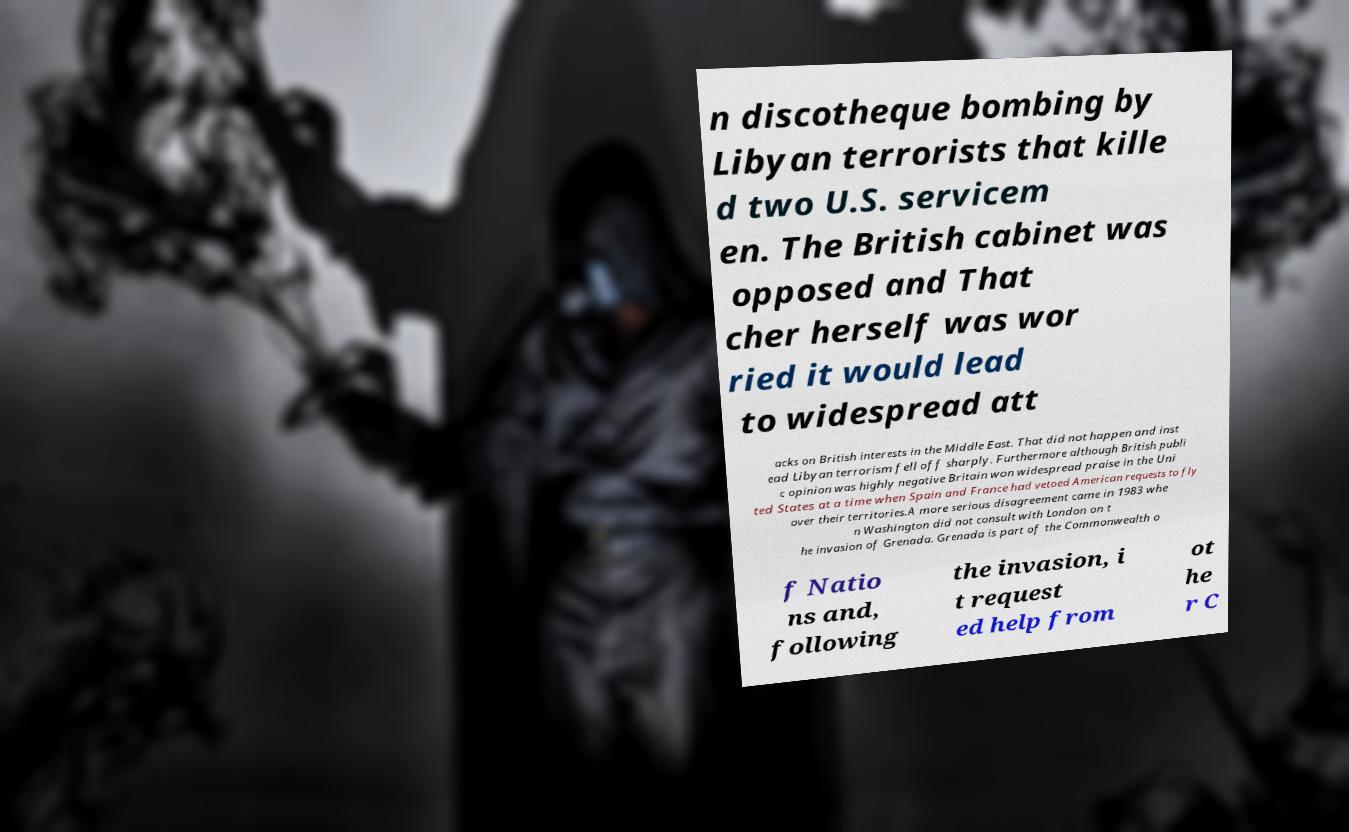There's text embedded in this image that I need extracted. Can you transcribe it verbatim? n discotheque bombing by Libyan terrorists that kille d two U.S. servicem en. The British cabinet was opposed and That cher herself was wor ried it would lead to widespread att acks on British interests in the Middle East. That did not happen and inst ead Libyan terrorism fell off sharply. Furthermore although British publi c opinion was highly negative Britain won widespread praise in the Uni ted States at a time when Spain and France had vetoed American requests to fly over their territories.A more serious disagreement came in 1983 whe n Washington did not consult with London on t he invasion of Grenada. Grenada is part of the Commonwealth o f Natio ns and, following the invasion, i t request ed help from ot he r C 